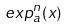<formula> <loc_0><loc_0><loc_500><loc_500>e x p _ { a } ^ { n } ( x )</formula> 